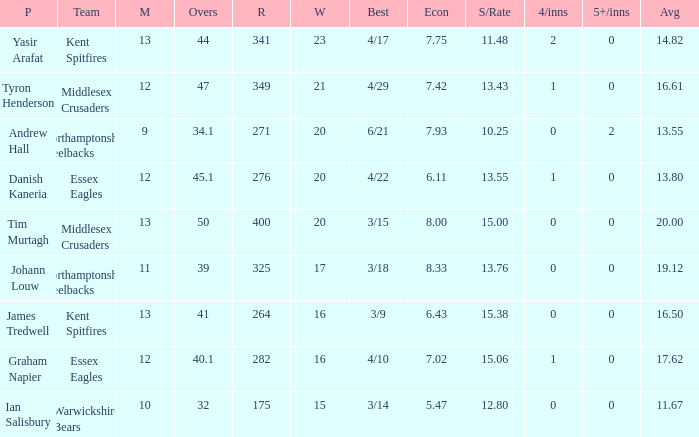Name the matches for wickets 17 11.0. 